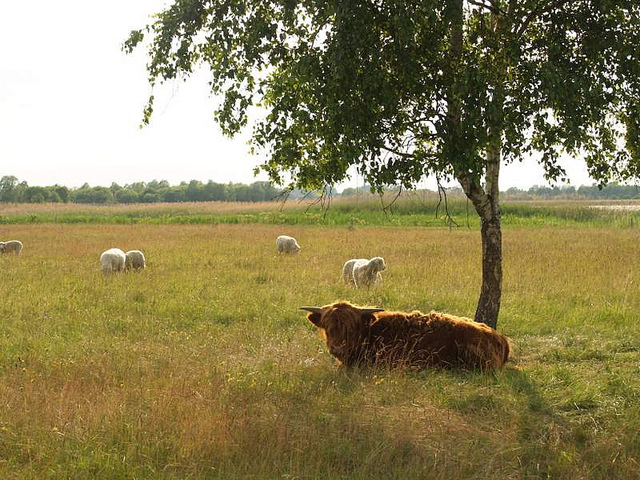<image>What kind of tree is this? I don't know the exact kind of tree it is. It may be an oak, spruce, or maple tree. What kind of tree is this? I don't know what kind of tree it is. It can be oak, maple, or spruce. 